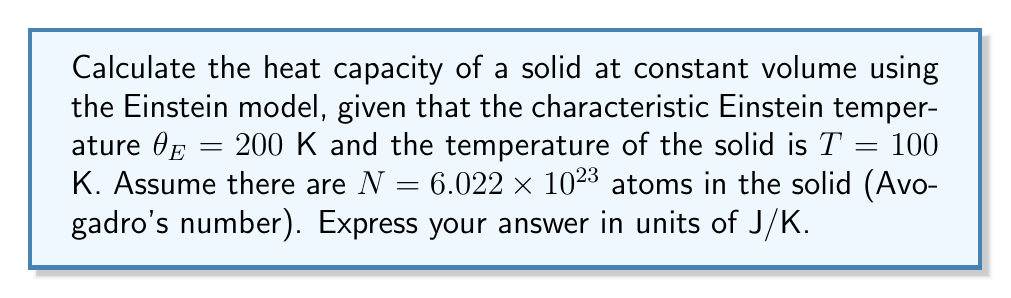Solve this math problem. To solve this problem, we'll use the Einstein model for the heat capacity of a solid. Let's break it down step-by-step:

1) The Einstein model gives the heat capacity at constant volume as:

   $$C_V = 3Nk_B \left(\frac{\theta_E}{T}\right)^2 \frac{e^{\theta_E/T}}{(e^{\theta_E/T}-1)^2}$$

   where $k_B$ is the Boltzmann constant.

2) We're given:
   $\theta_E = 200$ K
   $T = 100$ K
   $N = 6.022 \times 10^{23}$

3) Let's calculate $\theta_E/T$:
   $$\frac{\theta_E}{T} = \frac{200}{100} = 2$$

4) Now, let's substitute this into our equation:

   $$C_V = 3Nk_B (2)^2 \frac{e^2}{(e^2-1)^2}$$

5) We know that $k_B = 1.380649 \times 10^{-23}$ J/K

6) Let's calculate the exponential terms:
   $e^2 \approx 7.389$
   $(e^2-1)^2 \approx 40.771$

7) Substituting all of this in:

   $$C_V = 3 \cdot (6.022 \times 10^{23}) \cdot (1.380649 \times 10^{-23}) \cdot 4 \cdot \frac{7.389}{40.771}$$

8) Simplifying:

   $$C_V \approx 3 \cdot 6.022 \cdot 1.380649 \cdot 4 \cdot 0.1813$$

9) Calculating the final result:

   $$C_V \approx 18.13 \text{ J/K}$$
Answer: 18.13 J/K 